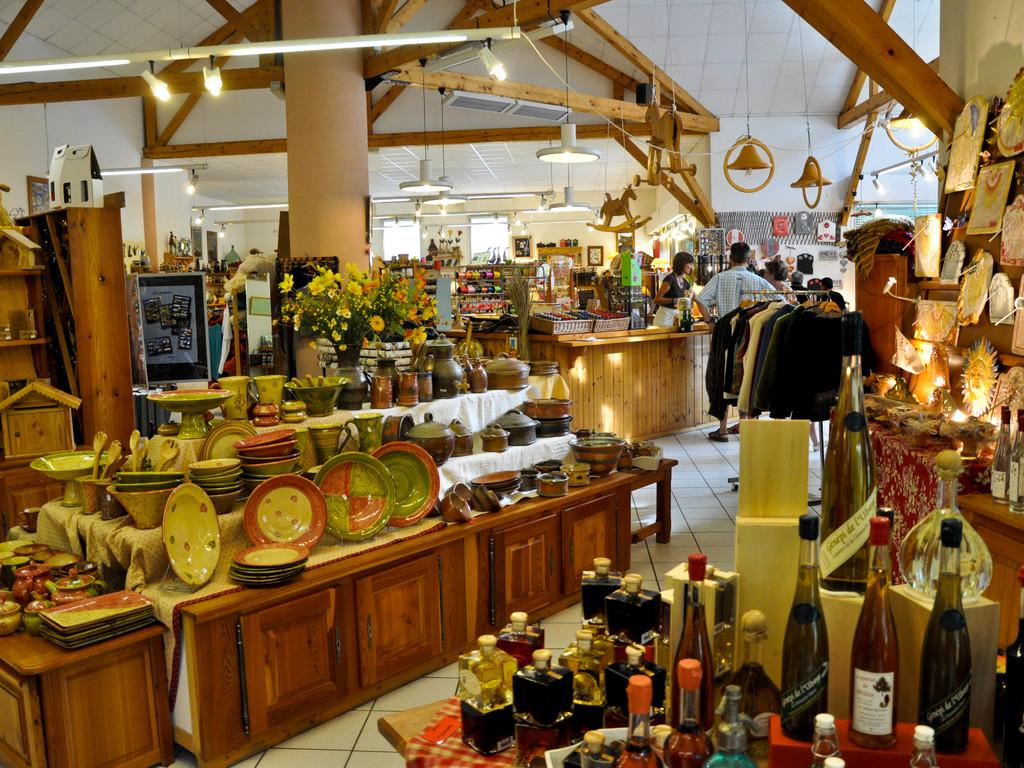How many people are present in the image? There is a group of people in the image, but the exact number cannot be determined from the provided facts. What objects are on the table in the image? There are plates, bottles, a flower vase, and bowls on the table in the image. What can be seen at the top of the image? There are lights visible at the top of the image. What is visible at the back of the image? There is a window at the back of the image. What type of berry is being used as a decoration on the cakes in the image? There is no mention of cakes or berries in the provided facts, so it cannot be determined from the image. 